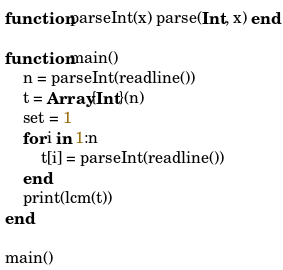<code> <loc_0><loc_0><loc_500><loc_500><_Julia_>function parseInt(x) parse(Int, x) end

function main()
	n = parseInt(readline())
	t = Array{Int}(n)
	set = 1
	for i in 1:n
		t[i] = parseInt(readline())
	end
	print(lcm(t))
end

main()</code> 